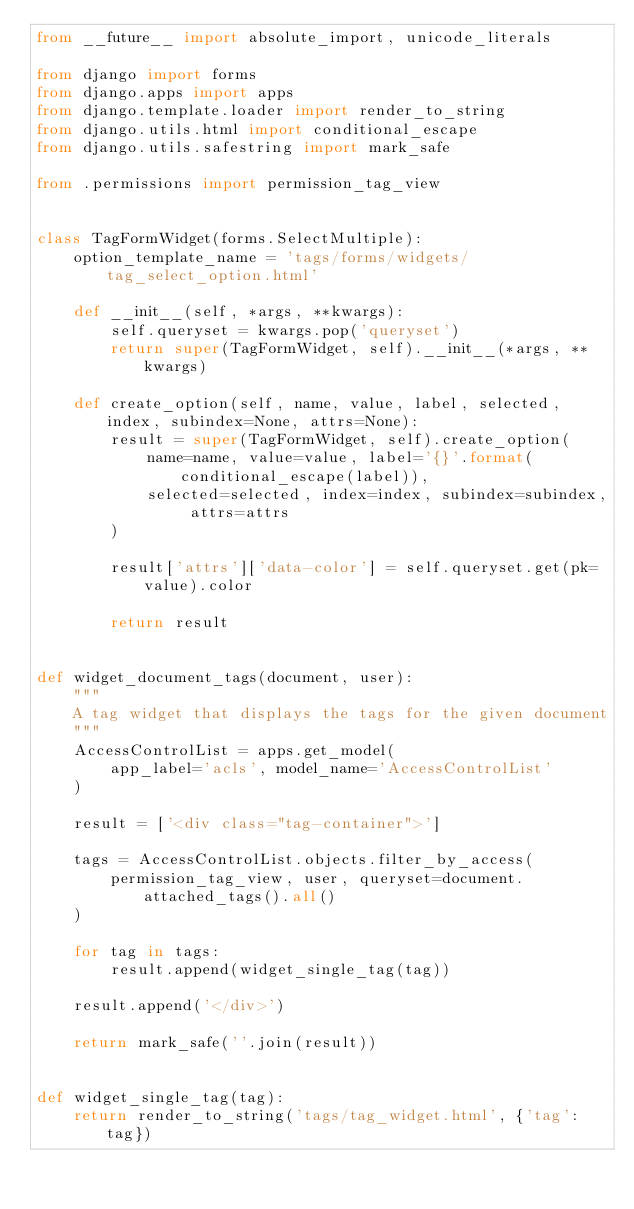Convert code to text. <code><loc_0><loc_0><loc_500><loc_500><_Python_>from __future__ import absolute_import, unicode_literals

from django import forms
from django.apps import apps
from django.template.loader import render_to_string
from django.utils.html import conditional_escape
from django.utils.safestring import mark_safe

from .permissions import permission_tag_view


class TagFormWidget(forms.SelectMultiple):
    option_template_name = 'tags/forms/widgets/tag_select_option.html'

    def __init__(self, *args, **kwargs):
        self.queryset = kwargs.pop('queryset')
        return super(TagFormWidget, self).__init__(*args, **kwargs)

    def create_option(self, name, value, label, selected, index, subindex=None, attrs=None):
        result = super(TagFormWidget, self).create_option(
            name=name, value=value, label='{}'.format(conditional_escape(label)),
            selected=selected, index=index, subindex=subindex, attrs=attrs
        )

        result['attrs']['data-color'] = self.queryset.get(pk=value).color

        return result


def widget_document_tags(document, user):
    """
    A tag widget that displays the tags for the given document
    """
    AccessControlList = apps.get_model(
        app_label='acls', model_name='AccessControlList'
    )

    result = ['<div class="tag-container">']

    tags = AccessControlList.objects.filter_by_access(
        permission_tag_view, user, queryset=document.attached_tags().all()
    )

    for tag in tags:
        result.append(widget_single_tag(tag))

    result.append('</div>')

    return mark_safe(''.join(result))


def widget_single_tag(tag):
    return render_to_string('tags/tag_widget.html', {'tag': tag})
</code> 